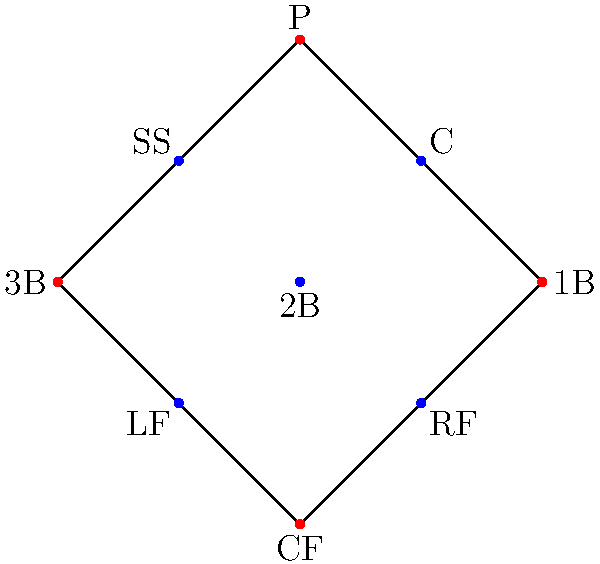As the operations manager, you're tasked with optimizing the team's defensive positioning. Given the diagram of a baseball diamond with player positions marked, which position would you recommend shifting slightly towards right field to create a more effective defensive alignment against a left-handed pull hitter? To answer this question, we need to consider the following steps:

1. Understand the scenario: We're dealing with a left-handed pull hitter, who tends to hit the ball towards the right side of the field.

2. Analyze the current positioning:
   - The diagram shows the standard positioning of players on a baseball diamond.
   - Each position is marked with its abbreviation (P, C, 1B, 2B, 3B, SS, LF, CF, RF).

3. Consider the tendencies of a left-handed pull hitter:
   - They are more likely to hit the ball between first and second base, or to right field.

4. Evaluate which position could be most effective if shifted:
   - The shortstop (SS) is typically responsible for the area between second and third base.
   - By shifting the shortstop slightly towards second base, we can:
     a) Provide better coverage for balls hit between first and second base.
     b) Allow the third baseman to cover more of the left side of the infield.

5. Consider the impact on overall defensive alignment:
   - This shift doesn't significantly weaken other areas of defense.
   - It creates a stronger defense against the pull hitter's tendencies.

Therefore, the most effective position to shift slightly towards right field would be the shortstop (SS).
Answer: Shortstop (SS) 